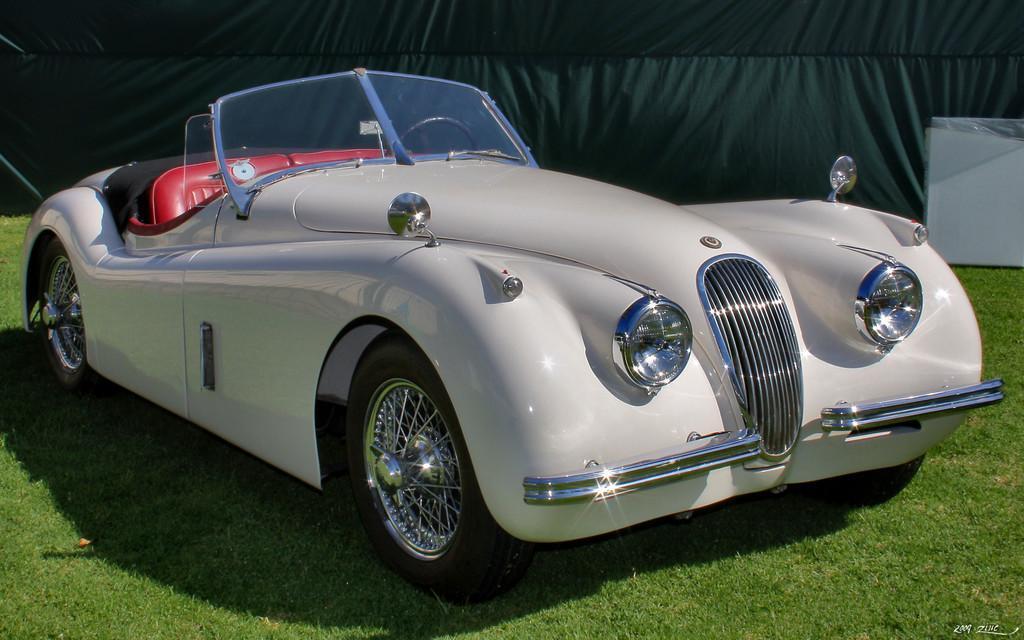Can you describe this image briefly? In this image in the front there is a car and there's grass on the ground. In the background there is a curtain which is black in colour and there is an object which is white in colour. 